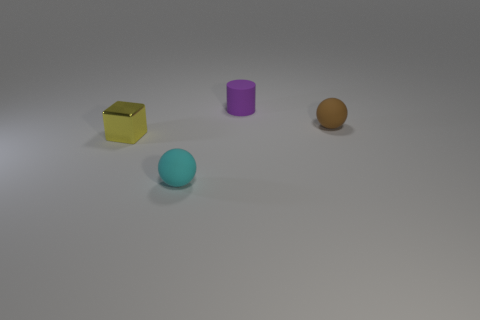Add 1 small cyan matte cylinders. How many objects exist? 5 Subtract 1 balls. How many balls are left? 1 Subtract all cubes. How many objects are left? 3 Add 1 brown things. How many brown things exist? 2 Subtract 1 purple cylinders. How many objects are left? 3 Subtract all red blocks. Subtract all red cylinders. How many blocks are left? 1 Subtract all red cylinders. How many brown spheres are left? 1 Subtract all large green shiny balls. Subtract all small spheres. How many objects are left? 2 Add 2 cyan rubber balls. How many cyan rubber balls are left? 3 